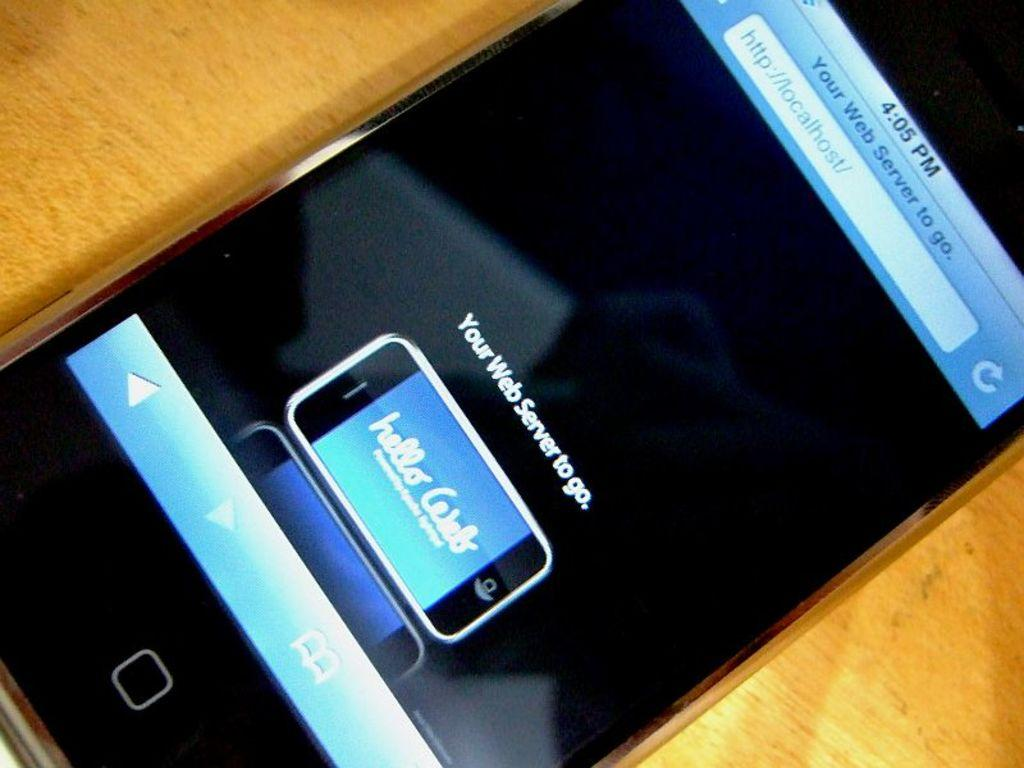<image>
Share a concise interpretation of the image provided. A cell phone which is on the website localhost.com 